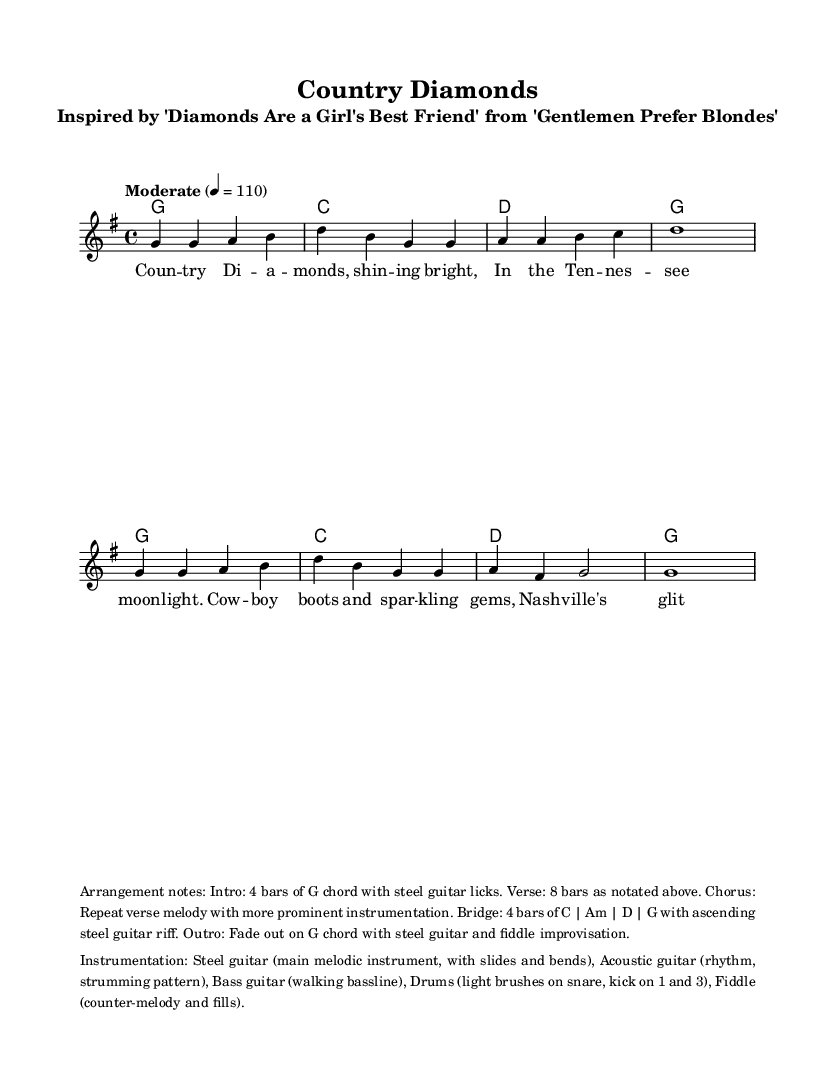What is the key signature of this music? The key signature is G major, which has one sharp (F#) indicated at the beginning of the score.
Answer: G major What is the time signature of the piece? The time signature, shown in the beginning of the score, is 4/4, meaning there are four beats in each measure and the quarter note gets one beat.
Answer: 4/4 What is the tempo marking for this piece? The tempo marking indicates a moderate speed of 110 beats per minute, as specified in the score.
Answer: Moderate 4 = 110 How many bars are in the intro section? The arrangement notes indicate an intro of 4 bars, as described in the markings before the music starts.
Answer: 4 bars What instruments are included in the instrumentation? The instrumentation includes a steel guitar, acoustic guitar, bass guitar, drums, and fiddle, as listed in the arrangement notes.
Answer: Steel guitar, acoustic guitar, bass guitar, drums, fiddle What is the structure of the music described in the arrangement notes? The arrangement notes detail a structure consisting of an intro, verse, chorus, bridge, and outro, which outlines the form of the music.
Answer: Intro, verse, chorus, bridge, outro What is the theme of the lyrics in this piece? The lyrics express a theme of country diamonds and imagery associated with shining and Nashville, linked with a joyful, country aesthetic.
Answer: Country diamonds and Nashville 